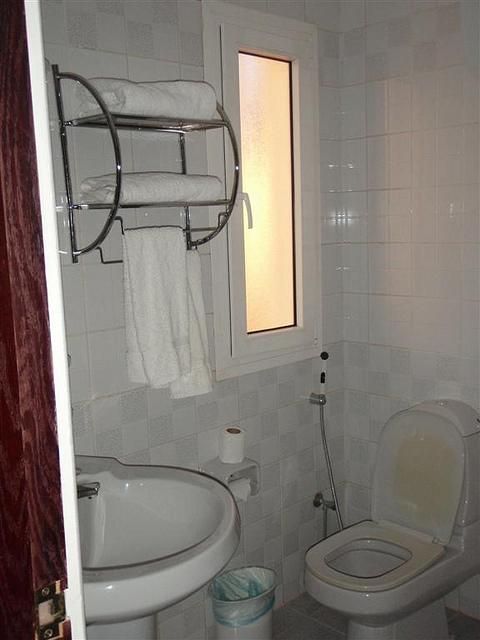What room is this?
Concise answer only. Bathroom. Can you see the toilet?
Concise answer only. Yes. Where is the toilet roll?
Quick response, please. Wall. Is the sink clean?
Keep it brief. Yes. 